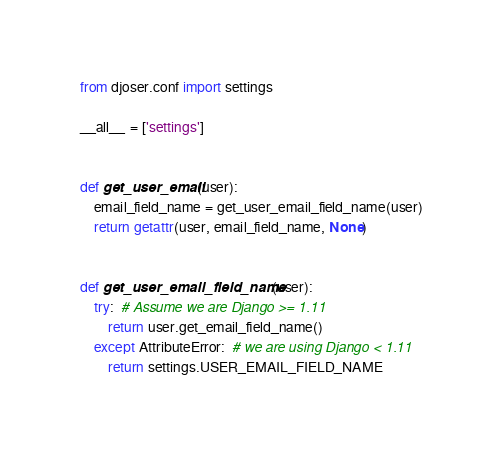Convert code to text. <code><loc_0><loc_0><loc_500><loc_500><_Python_>from djoser.conf import settings

__all__ = ['settings']


def get_user_email(user):
    email_field_name = get_user_email_field_name(user)
    return getattr(user, email_field_name, None)


def get_user_email_field_name(user):
    try:  # Assume we are Django >= 1.11
        return user.get_email_field_name()
    except AttributeError:  # we are using Django < 1.11
        return settings.USER_EMAIL_FIELD_NAME
</code> 